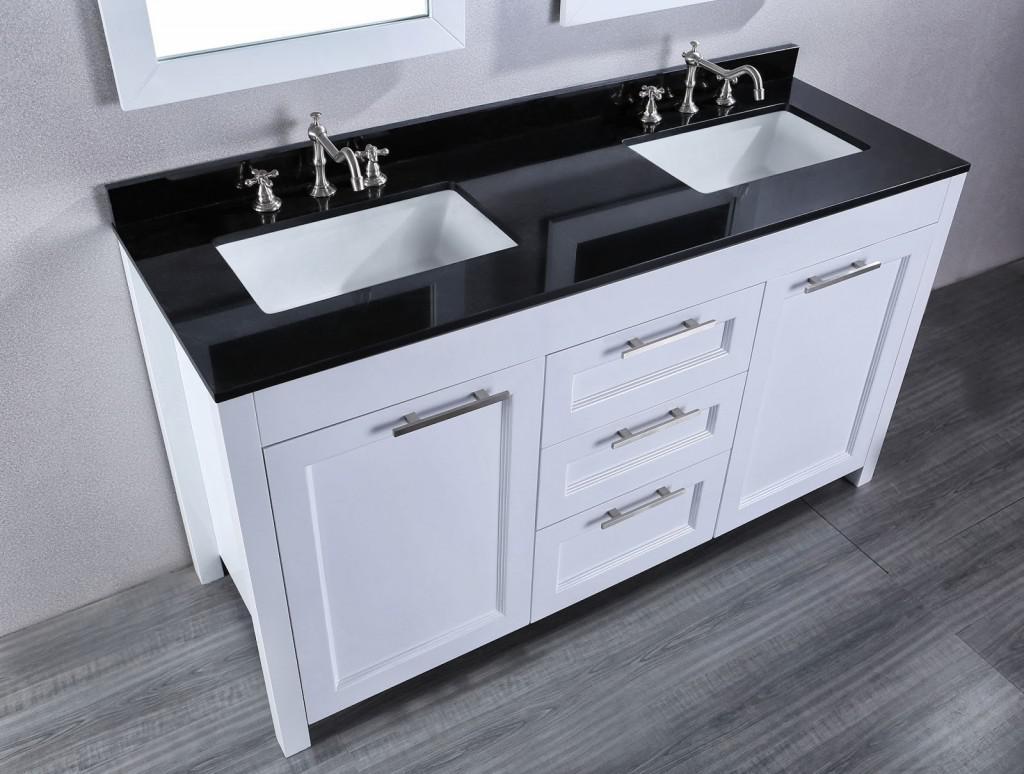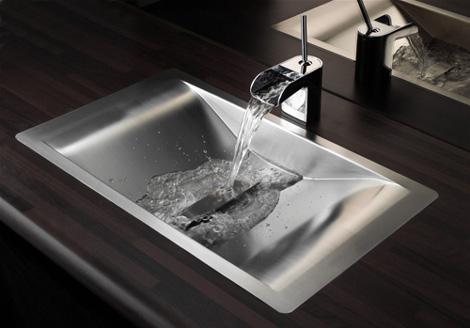The first image is the image on the left, the second image is the image on the right. Considering the images on both sides, is "The counter in the image on the left is black and has two white sinks." valid? Answer yes or no. Yes. The first image is the image on the left, the second image is the image on the right. Examine the images to the left and right. Is the description "An image shows a top-view of a black-and-white sink and vanity combination, with two rectangular sinks inset in the counter, and a mirror above each sink." accurate? Answer yes or no. Yes. 